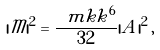<formula> <loc_0><loc_0><loc_500><loc_500>| \mathcal { M } | ^ { 2 } = \frac { \ m k k ^ { 6 } } { 3 2 } | A | ^ { 2 } \, ,</formula> 